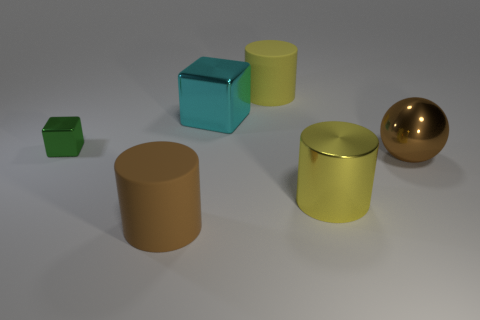What materials seem to be represented by the objects in this image? The objects in the image seem to represent materials with various properties. The blue and green cubes appear to have a matte finish suggesting a clay or matte-painted texture. The two cylinders seem to have a dull metallic or plastic appearance, and the sphere has a shiny, reflective surface, possibly representing a polished metal or a glossy plastic. 